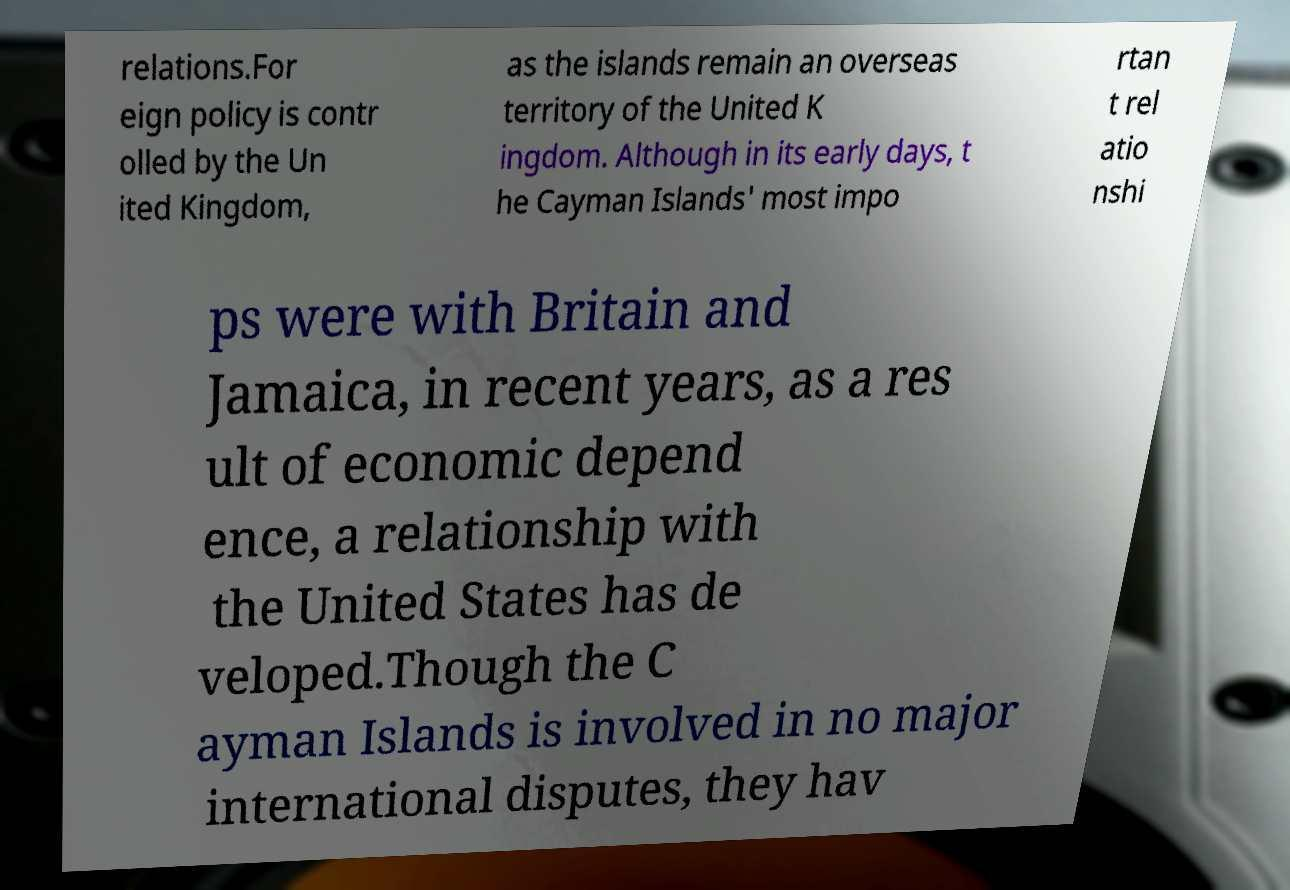Can you accurately transcribe the text from the provided image for me? relations.For eign policy is contr olled by the Un ited Kingdom, as the islands remain an overseas territory of the United K ingdom. Although in its early days, t he Cayman Islands' most impo rtan t rel atio nshi ps were with Britain and Jamaica, in recent years, as a res ult of economic depend ence, a relationship with the United States has de veloped.Though the C ayman Islands is involved in no major international disputes, they hav 